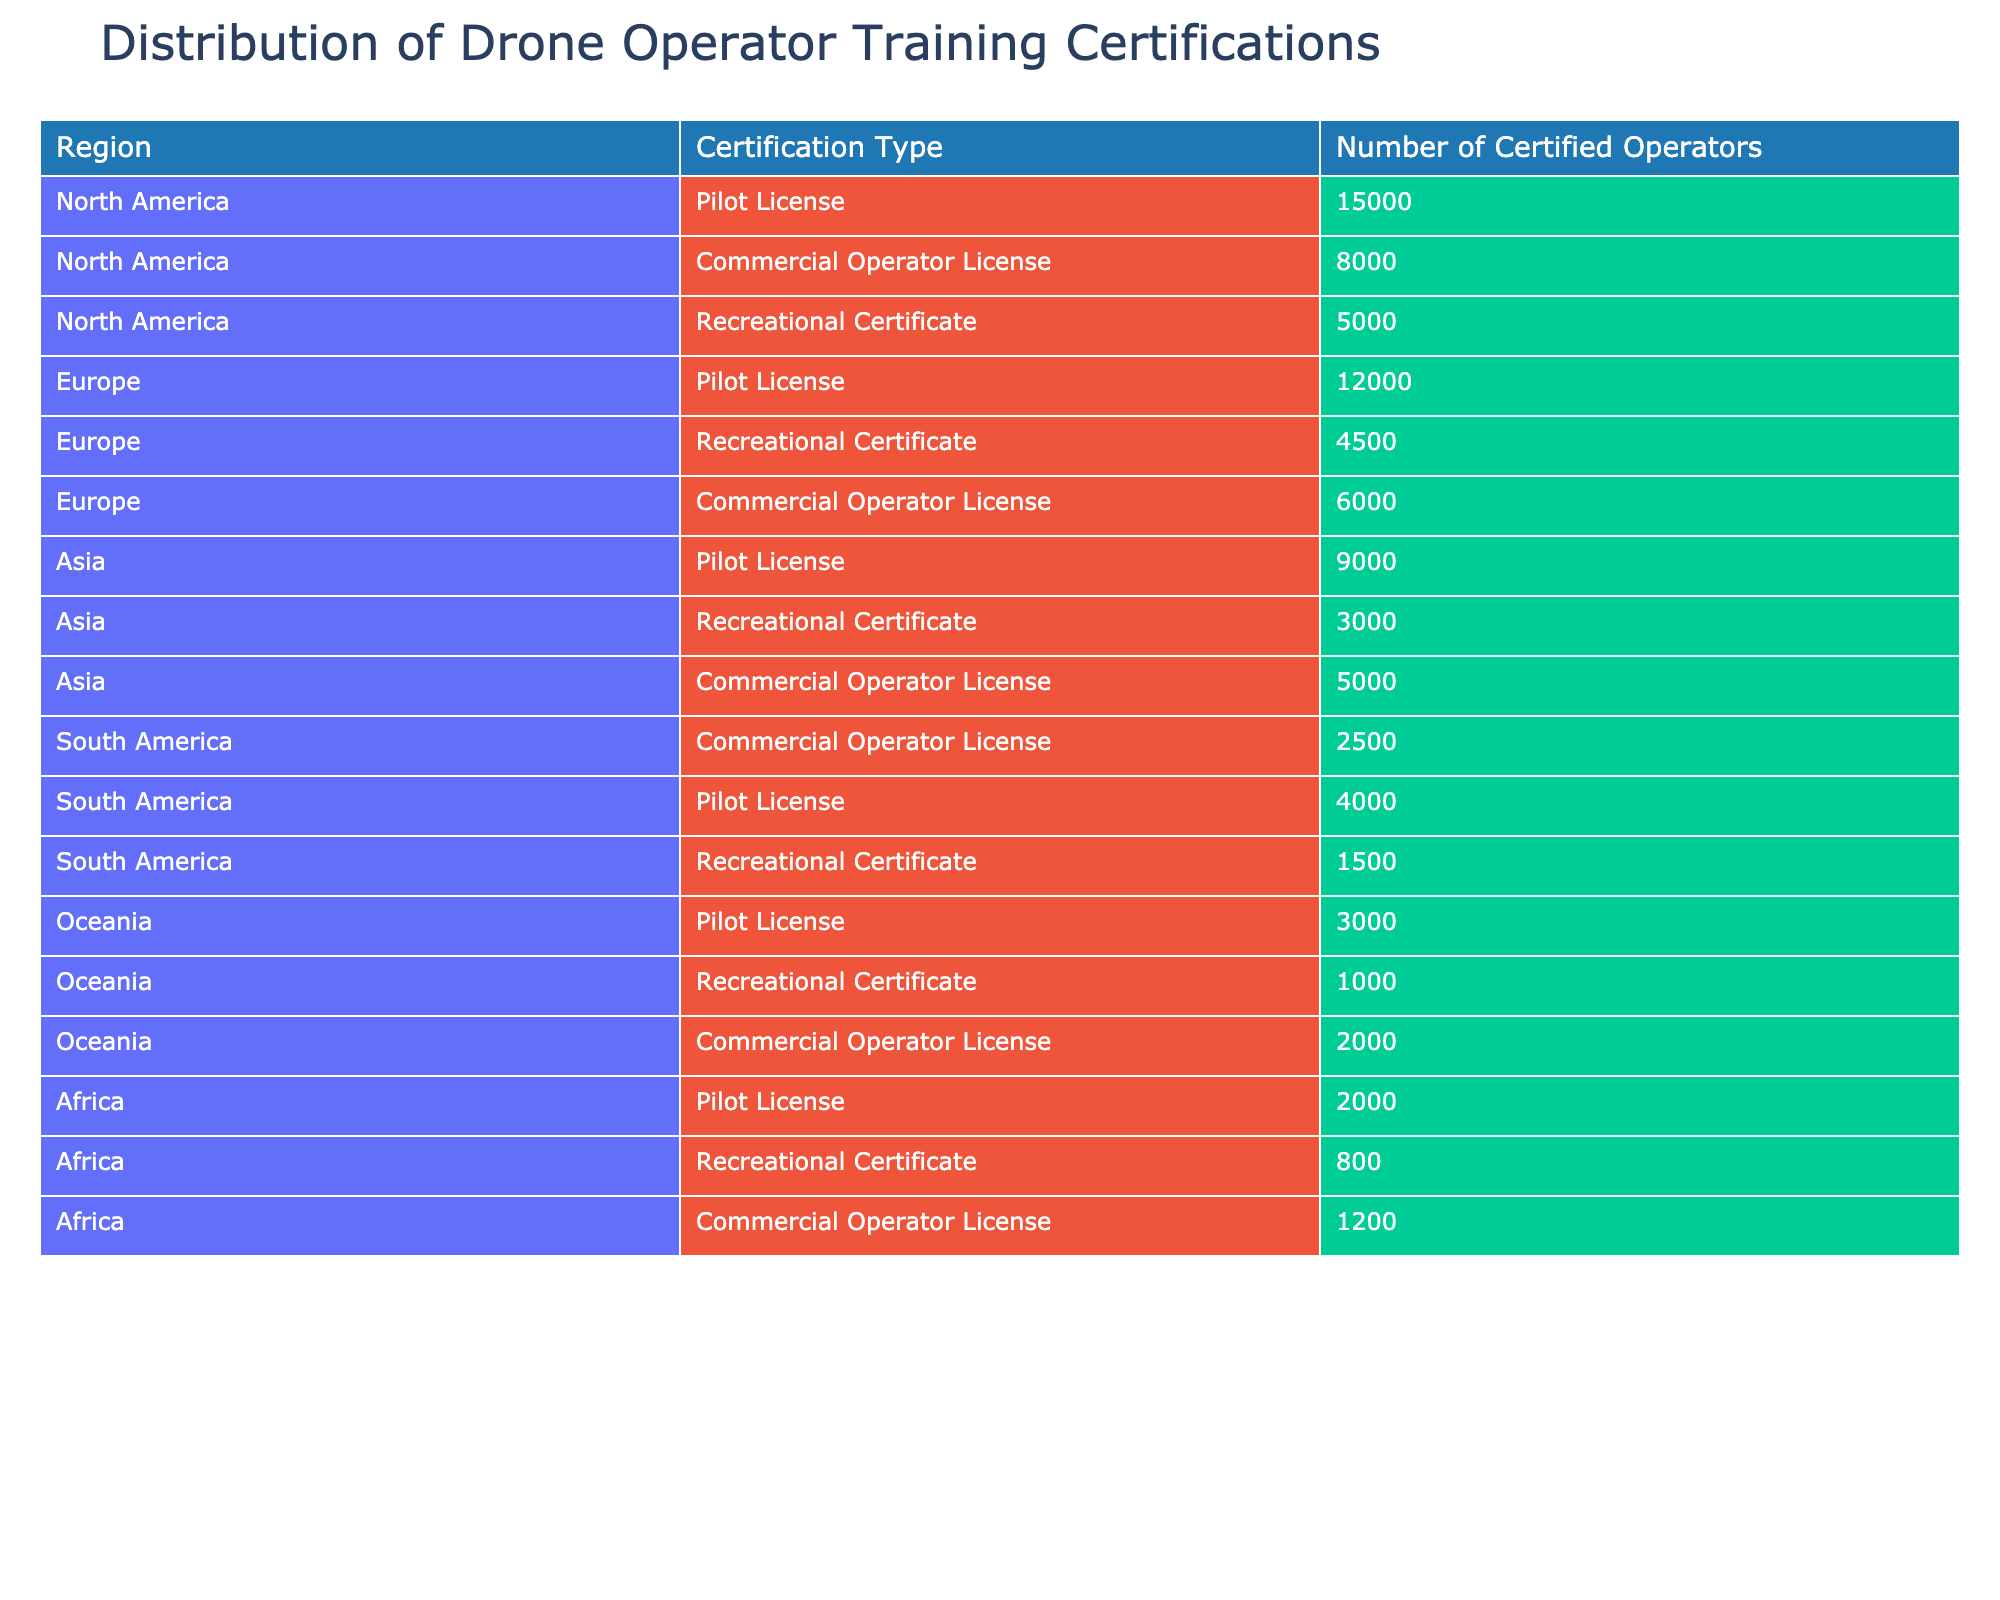What is the total number of certified operators in North America? In the table, we look at the rows corresponding to North America. The numbers are 15000 for Pilot License, 5000 for Recreational Certificate, and 8000 for Commercial Operator License. Adding these together gives 15000 + 5000 + 8000 = 28000.
Answer: 28000 Which region has the highest number of certified operators for the Recreational Certificate? From the table, we check the Recreational Certificates across all regions. North America has 5000, Europe has 4500, Asia has 3000, South America has 1500, Oceania has 1000, and Africa has 800. The highest value is 5000 from North America.
Answer: North America How many more certified operators are there in Europe for the Pilot License compared to South America? We find the numbers for Pilot License in Europe and South America from the table. Europe has 12000 certified operators, while South America has 4000. The difference is 12000 - 4000 = 8000.
Answer: 8000 Is there a higher total number of certified operators in Asia or South America? We need to calculate the total for both regions. Asia has 9000 (Pilot) + 3000 (Recreational) + 5000 (Commercial) = 17000 certified operators. South America has 4000 (Pilot) + 1500 (Recreational) + 2500 (Commercial) = 8000. Since 17000 is greater than 8000, Asia has more certified operators.
Answer: Yes, Asia has a higher total What percentage of the total number of certified operators in Oceania are Pilot License holders? First, we calculate the total number of certified operators in Oceania: 3000 (Pilot) + 1000 (Recreational) + 2000 (Commercial) = 6000. Then we determine the percentage of Pilot License holders: (3000 / 6000) * 100 = 50%.
Answer: 50% Which certification type has the lowest sum across all regions? We sum the certified operators for each certification type across all regions. For Pilot License, the total is 15000 + 12000 + 9000 + 4000 + 3000 + 2000 = 60000. For Recreational Certificate, the total is 5000 + 4500 + 3000 + 1500 + 1000 + 800 = 16300. For Commercial Operator License, the total is 8000 + 6000 + 5000 + 2500 + 2000 + 1200 = 25000. The lowest sum is for Recreational Certificate at 16300.
Answer: Recreational Certificate Is the number of certified operators for Commercial Operator License in Africa greater than the number in Oceania? Checking the table, Africa has 1200 certified operators for Commercial License while Oceania has 2000. Since 1200 is less than 2000, the statement is false.
Answer: No What is the ratio of the number of certified operators for Commercial Operator License in North America to those in South America? We extract the numbers from the table: North America has 8000 for Commercial Operator License, and South America has 2500. The ratio is 8000:2500, which simplifies to 16:5.
Answer: 16:5 